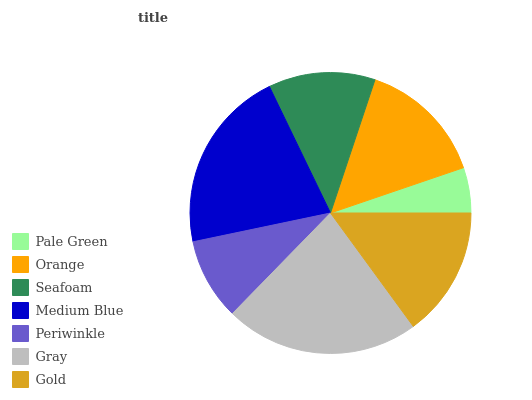Is Pale Green the minimum?
Answer yes or no. Yes. Is Gray the maximum?
Answer yes or no. Yes. Is Orange the minimum?
Answer yes or no. No. Is Orange the maximum?
Answer yes or no. No. Is Orange greater than Pale Green?
Answer yes or no. Yes. Is Pale Green less than Orange?
Answer yes or no. Yes. Is Pale Green greater than Orange?
Answer yes or no. No. Is Orange less than Pale Green?
Answer yes or no. No. Is Orange the high median?
Answer yes or no. Yes. Is Orange the low median?
Answer yes or no. Yes. Is Medium Blue the high median?
Answer yes or no. No. Is Gold the low median?
Answer yes or no. No. 